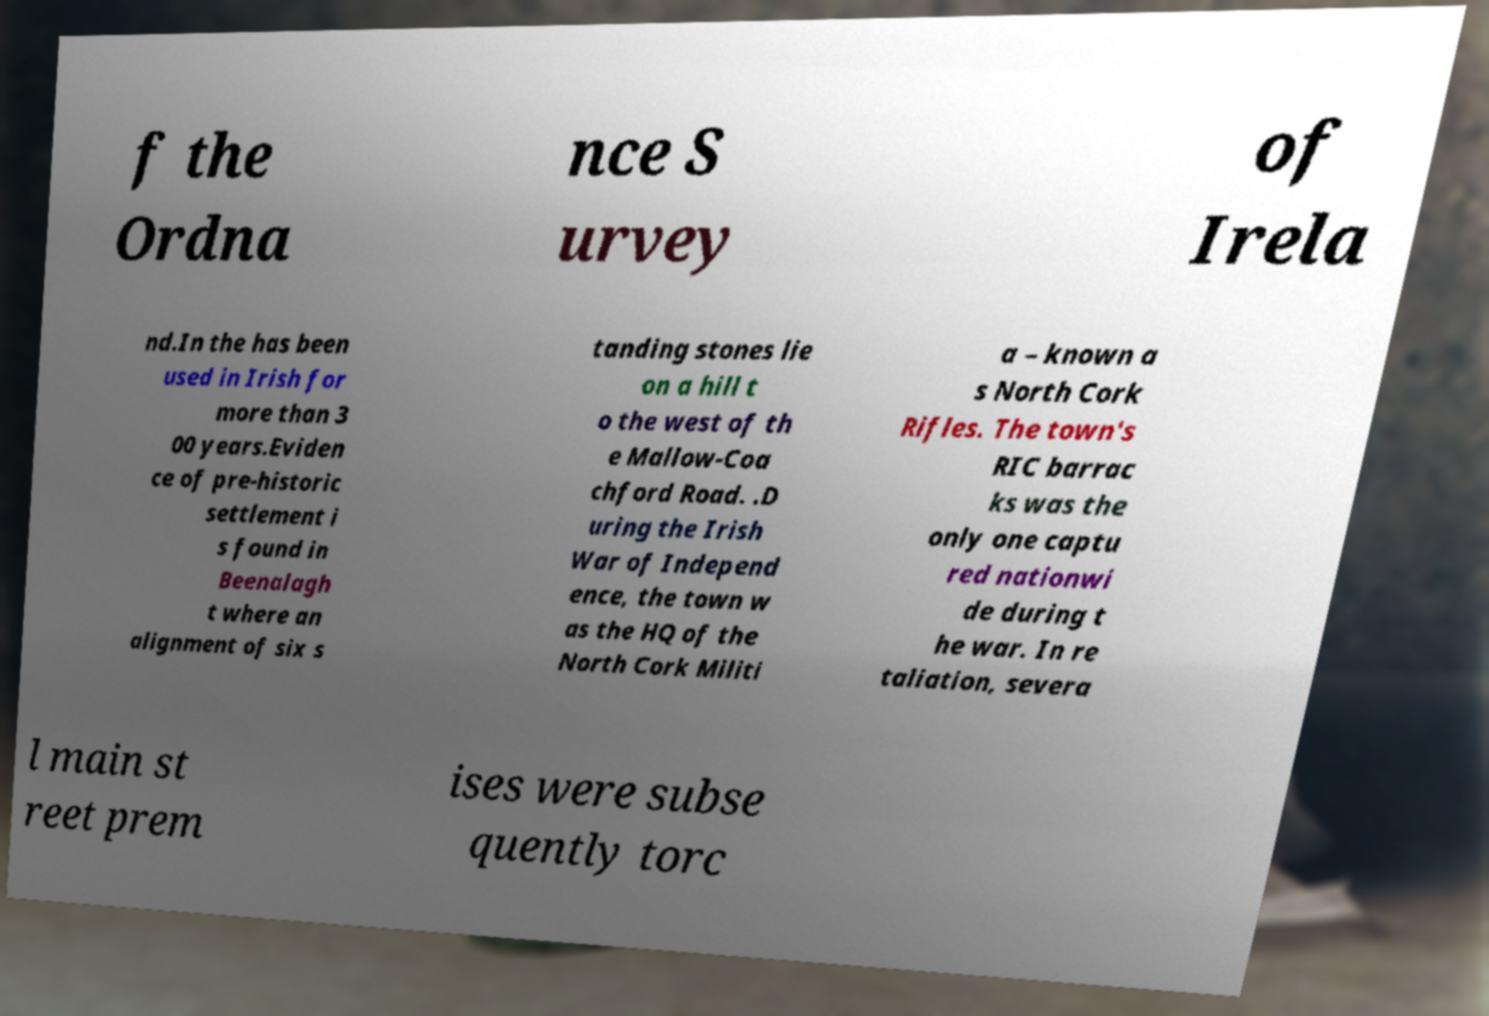I need the written content from this picture converted into text. Can you do that? f the Ordna nce S urvey of Irela nd.In the has been used in Irish for more than 3 00 years.Eviden ce of pre-historic settlement i s found in Beenalagh t where an alignment of six s tanding stones lie on a hill t o the west of th e Mallow-Coa chford Road. .D uring the Irish War of Independ ence, the town w as the HQ of the North Cork Militi a – known a s North Cork Rifles. The town's RIC barrac ks was the only one captu red nationwi de during t he war. In re taliation, severa l main st reet prem ises were subse quently torc 